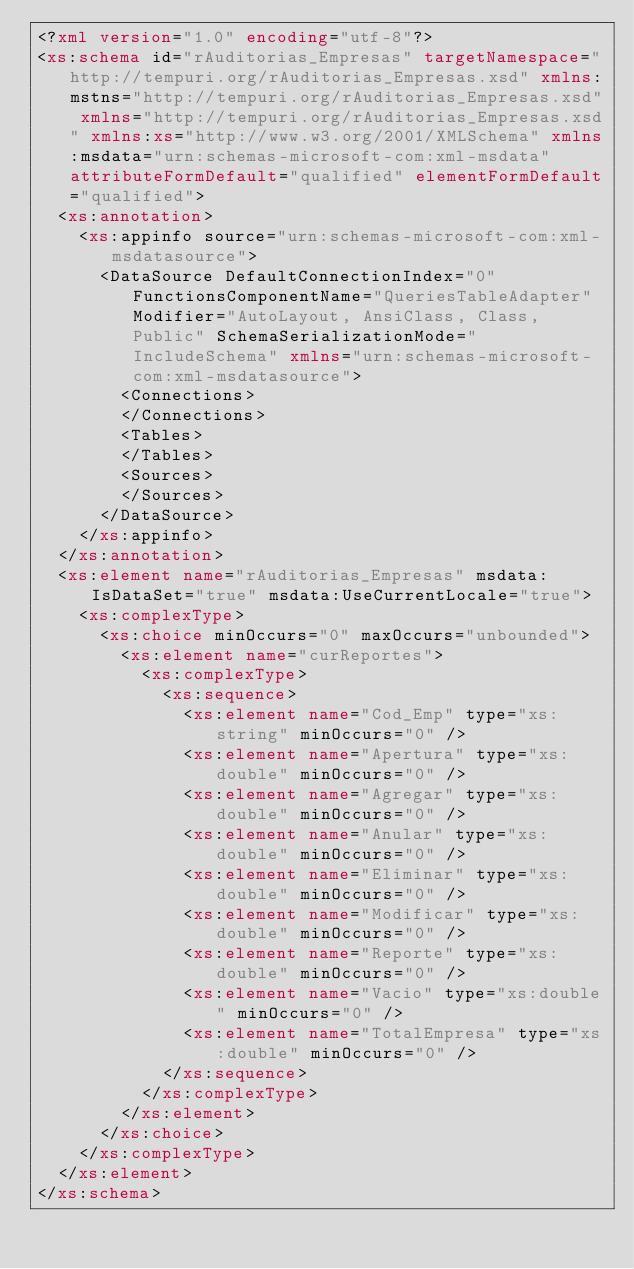Convert code to text. <code><loc_0><loc_0><loc_500><loc_500><_XML_><?xml version="1.0" encoding="utf-8"?>
<xs:schema id="rAuditorias_Empresas" targetNamespace="http://tempuri.org/rAuditorias_Empresas.xsd" xmlns:mstns="http://tempuri.org/rAuditorias_Empresas.xsd" xmlns="http://tempuri.org/rAuditorias_Empresas.xsd" xmlns:xs="http://www.w3.org/2001/XMLSchema" xmlns:msdata="urn:schemas-microsoft-com:xml-msdata" attributeFormDefault="qualified" elementFormDefault="qualified">
  <xs:annotation>
    <xs:appinfo source="urn:schemas-microsoft-com:xml-msdatasource">
      <DataSource DefaultConnectionIndex="0" FunctionsComponentName="QueriesTableAdapter" Modifier="AutoLayout, AnsiClass, Class, Public" SchemaSerializationMode="IncludeSchema" xmlns="urn:schemas-microsoft-com:xml-msdatasource">
        <Connections>
        </Connections>
        <Tables>
        </Tables>
        <Sources>
        </Sources>
      </DataSource>
    </xs:appinfo>
  </xs:annotation>
  <xs:element name="rAuditorias_Empresas" msdata:IsDataSet="true" msdata:UseCurrentLocale="true">
    <xs:complexType>
      <xs:choice minOccurs="0" maxOccurs="unbounded">
        <xs:element name="curReportes">
          <xs:complexType>
            <xs:sequence>
              <xs:element name="Cod_Emp" type="xs:string" minOccurs="0" />
              <xs:element name="Apertura" type="xs:double" minOccurs="0" />
              <xs:element name="Agregar" type="xs:double" minOccurs="0" />
              <xs:element name="Anular" type="xs:double" minOccurs="0" />
              <xs:element name="Eliminar" type="xs:double" minOccurs="0" />
              <xs:element name="Modificar" type="xs:double" minOccurs="0" />
              <xs:element name="Reporte" type="xs:double" minOccurs="0" />
              <xs:element name="Vacio" type="xs:double" minOccurs="0" />
              <xs:element name="TotalEmpresa" type="xs:double" minOccurs="0" />
            </xs:sequence>
          </xs:complexType>
        </xs:element>
      </xs:choice>
    </xs:complexType>
  </xs:element>
</xs:schema></code> 